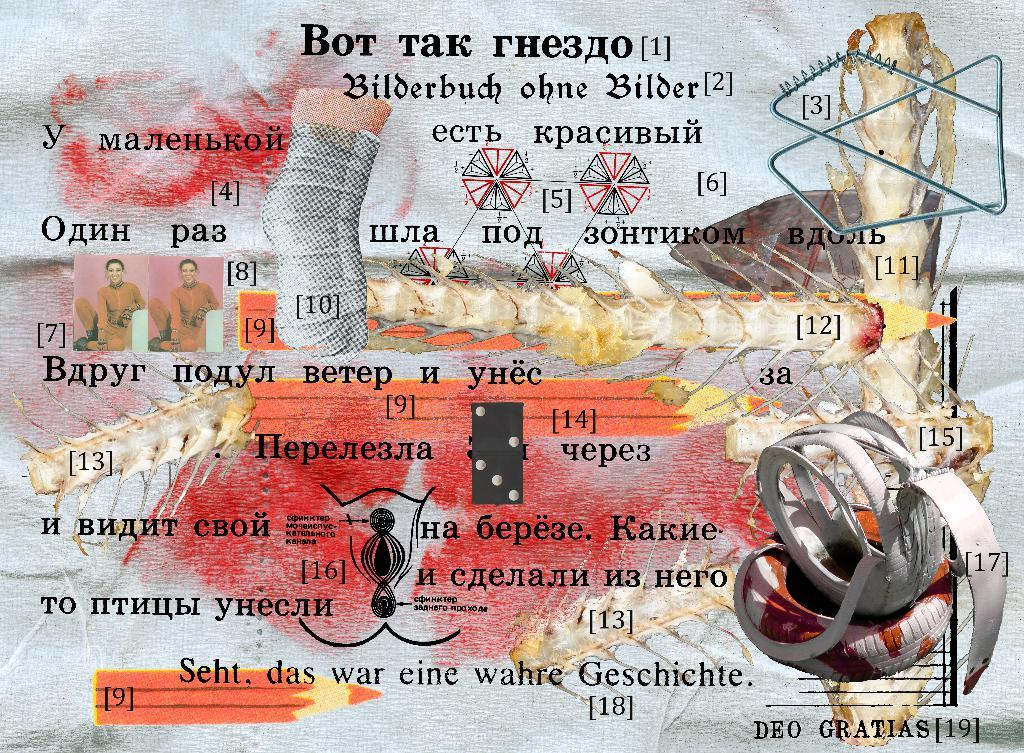What is the main subject in the image? There is a poster in the image. What can be seen on the left side of the poster? There are photos of a person attached to the poster on the left side. What is located in the bottom right corner of the image? There are designed objects in the bottom right corner of the image. What type of statement does the secretary make in the image? There is no secretary present in the image, so it is not possible to answer that question. 